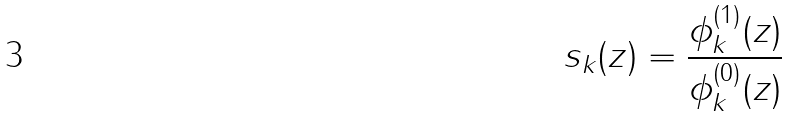<formula> <loc_0><loc_0><loc_500><loc_500>s _ { k } ( z ) = \frac { \phi _ { k } ^ { ( 1 ) } ( z ) } { \phi _ { k } ^ { ( 0 ) } ( z ) }</formula> 